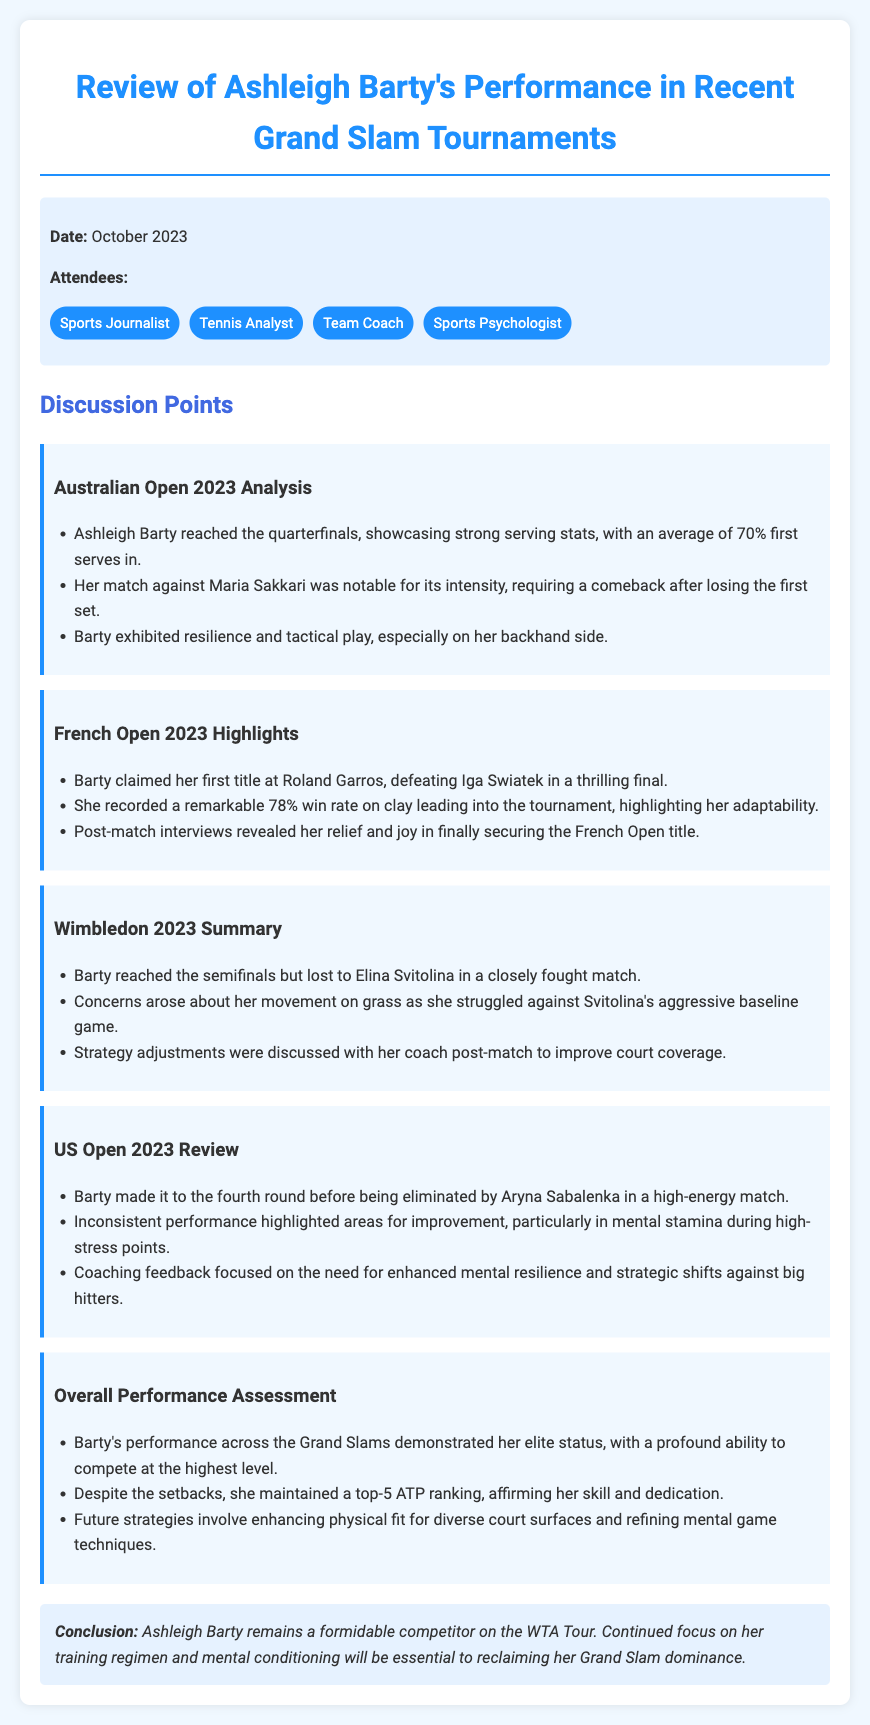What was Ashleigh Barty's performance in the Australian Open 2023? Barty reached the quarterfinals, showcasing strong serving stats, with an average of 70% first serves in.
Answer: Quarterfinals Which player did Barty defeat to win the French Open 2023? Barty claimed her first title at Roland Garros, defeating Iga Swiatek in a thrilling final.
Answer: Iga Swiatek How many Grand Slam tournaments are reviewed in the document? The document discusses Ashleigh Barty's performance across four tournaments: Australian Open, French Open, Wimbledon, and US Open.
Answer: Four What was a noted concern in Barty's Wimbledon performance? Concerns arose about her movement on grass as she struggled against Svitolina's aggressive baseline game.
Answer: Movement on grass What is one area for improvement noted in Barty's US Open performance? Inconsistent performance highlighted areas for improvement, particularly in mental stamina during high-stress points.
Answer: Mental stamina What is the conclusion about Ashleigh Barty's status on the WTA Tour? Ashleigh Barty remains a formidable competitor on the WTA Tour, with a focus on training and mental conditioning essential to reclaiming her Grand Slam dominance.
Answer: Formidable competitor What date is mentioned in the document? The meeting took place in October 2023, as noted in the meta-info section.
Answer: October 2023 What overall ATP ranking did Barty maintain despite setbacks? Despite the setbacks, she maintained a top-5 ATP ranking, affirming her skill and dedication.
Answer: Top-5 